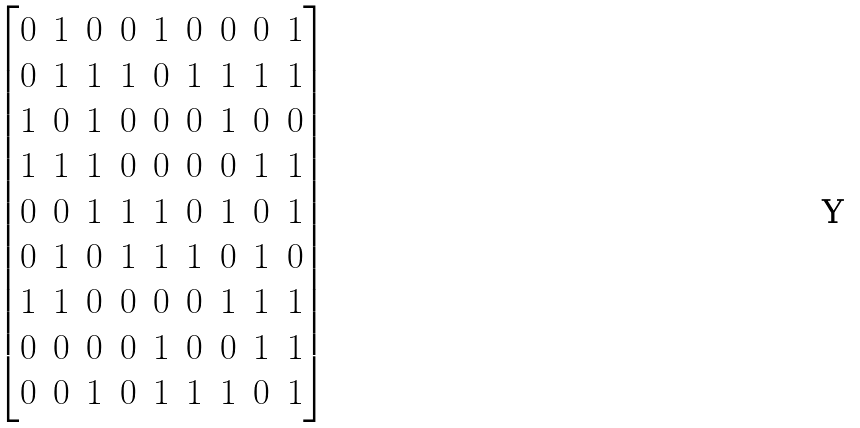<formula> <loc_0><loc_0><loc_500><loc_500>\begin{bmatrix} 0 & 1 & 0 & 0 & 1 & 0 & 0 & 0 & 1 \\ 0 & 1 & 1 & 1 & 0 & 1 & 1 & 1 & 1 \\ 1 & 0 & 1 & 0 & 0 & 0 & 1 & 0 & 0 \\ 1 & 1 & 1 & 0 & 0 & 0 & 0 & 1 & 1 \\ 0 & 0 & 1 & 1 & 1 & 0 & 1 & 0 & 1 \\ 0 & 1 & 0 & 1 & 1 & 1 & 0 & 1 & 0 \\ 1 & 1 & 0 & 0 & 0 & 0 & 1 & 1 & 1 \\ 0 & 0 & 0 & 0 & 1 & 0 & 0 & 1 & 1 \\ 0 & 0 & 1 & 0 & 1 & 1 & 1 & 0 & 1 \end{bmatrix}</formula> 